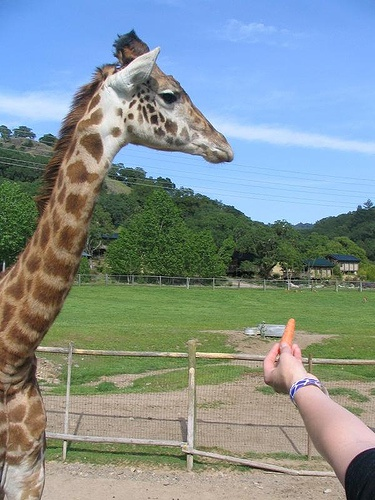Describe the objects in this image and their specific colors. I can see giraffe in gray, maroon, and darkgray tones, people in gray, pink, darkgray, and black tones, and carrot in gray, tan, and salmon tones in this image. 